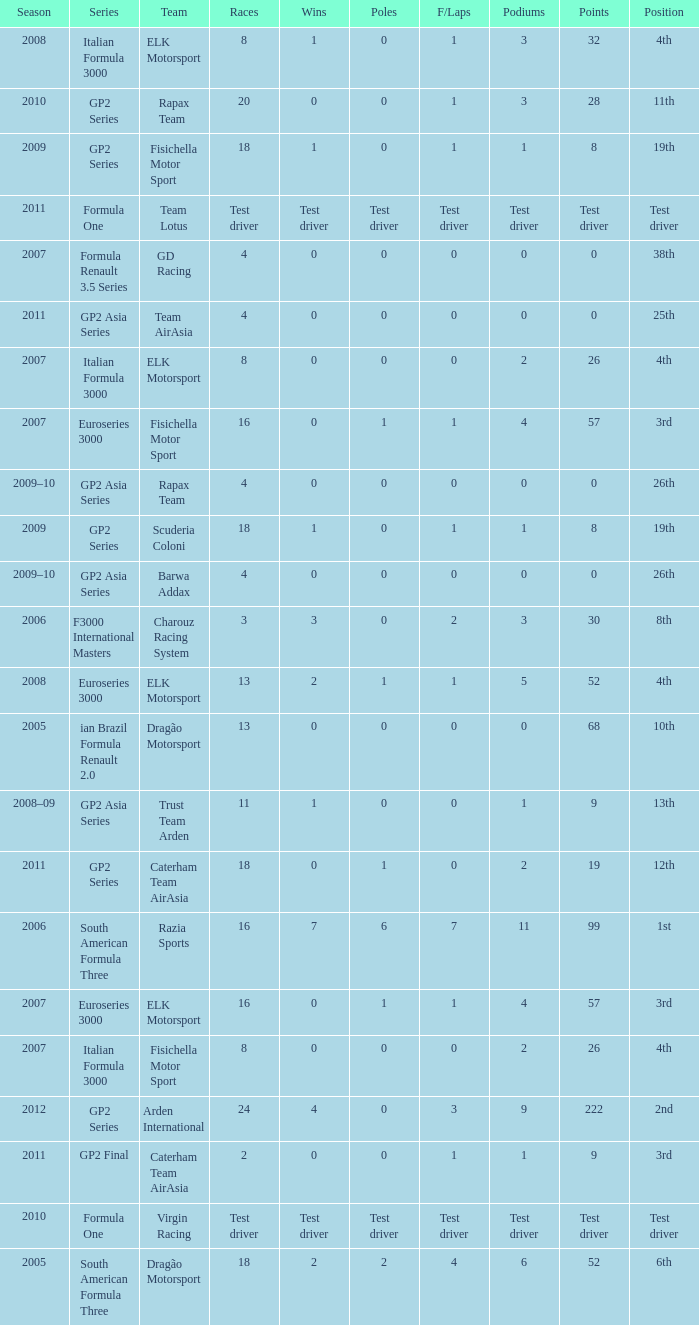What were the points in the year when his Wins were 0, his Podiums were 0, and he drove in 4 races? 0, 0, 0, 0. 